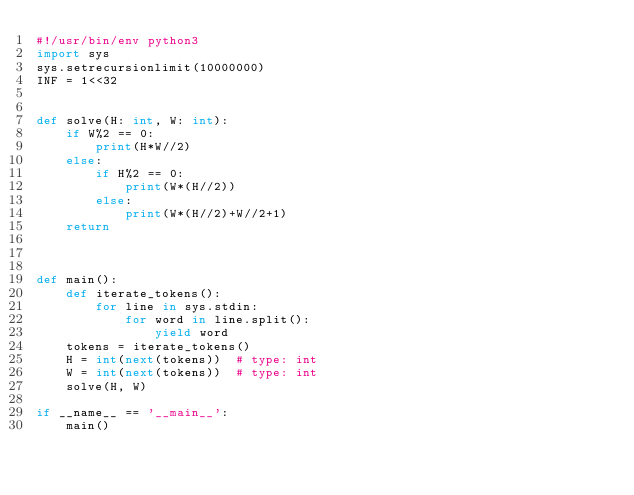<code> <loc_0><loc_0><loc_500><loc_500><_Python_>#!/usr/bin/env python3
import sys
sys.setrecursionlimit(10000000)
INF = 1<<32


def solve(H: int, W: int):
    if W%2 == 0:
        print(H*W//2)
    else:
        if H%2 == 0:
            print(W*(H//2))
        else:
            print(W*(H//2)+W//2+1)
    return



def main():
    def iterate_tokens():
        for line in sys.stdin:
            for word in line.split():
                yield word
    tokens = iterate_tokens()
    H = int(next(tokens))  # type: int
    W = int(next(tokens))  # type: int
    solve(H, W)

if __name__ == '__main__':
    main()
</code> 